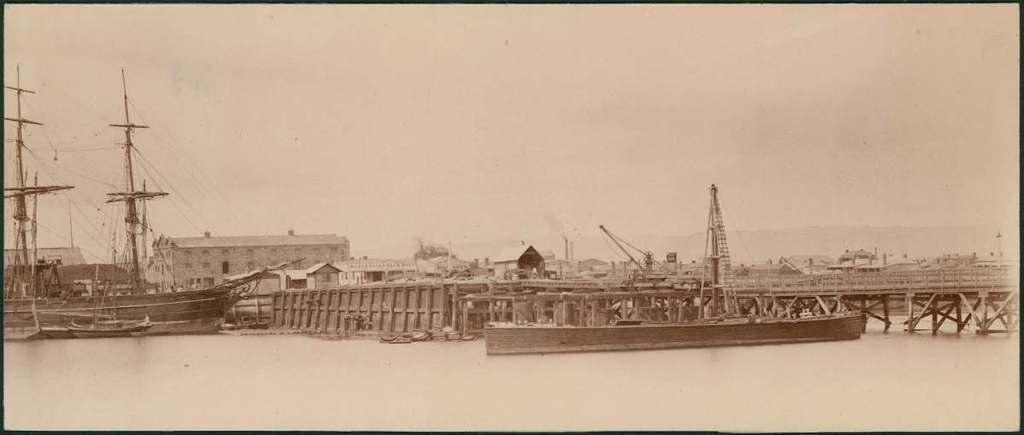What is the main element in the image? There is water in the image. What else can be seen in the water? There are boats in the image. What structures are visible in the background? There are buildings in the image. What are the current poles used for? Current poles are present in the image. What part of the natural environment is visible in the image? The sky is visible in the image. What type of cord is being used to connect the heart to the boat in the image? There is no cord or heart present in the image; it features water, boats, buildings, current poles, and the sky. 